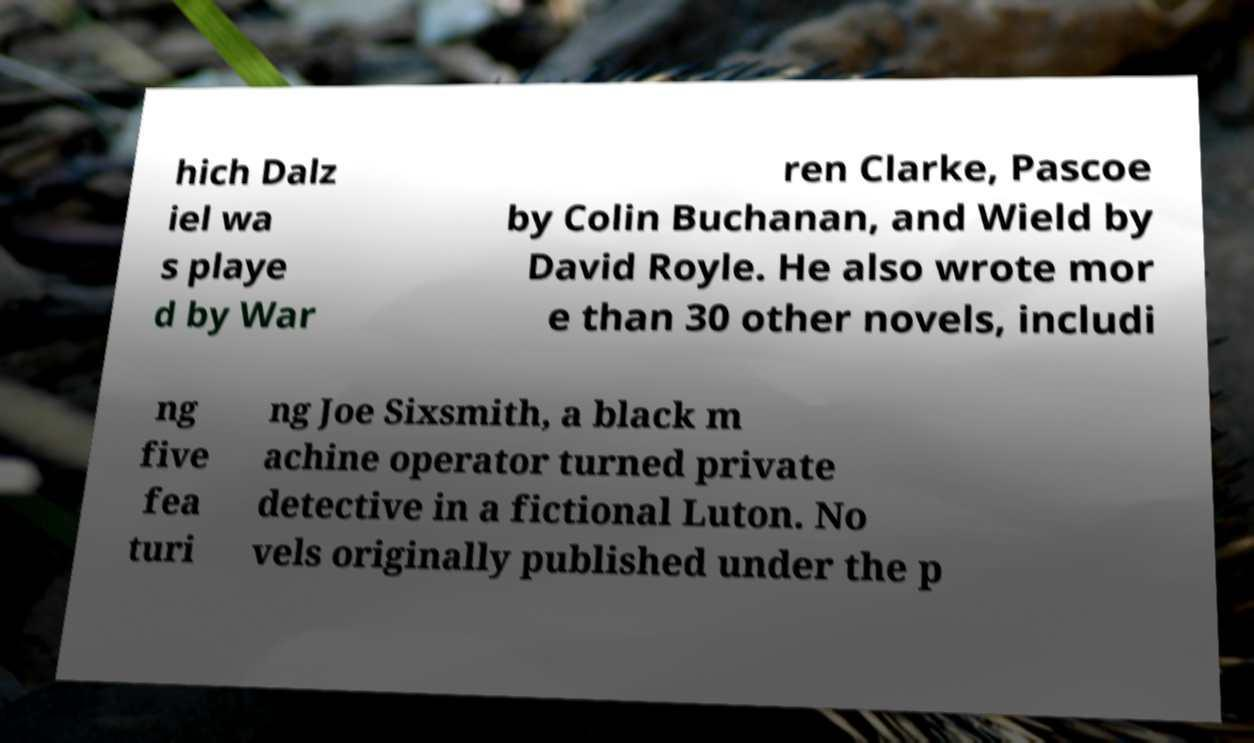Can you accurately transcribe the text from the provided image for me? hich Dalz iel wa s playe d by War ren Clarke, Pascoe by Colin Buchanan, and Wield by David Royle. He also wrote mor e than 30 other novels, includi ng five fea turi ng Joe Sixsmith, a black m achine operator turned private detective in a fictional Luton. No vels originally published under the p 